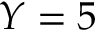Convert formula to latex. <formula><loc_0><loc_0><loc_500><loc_500>Y = 5</formula> 